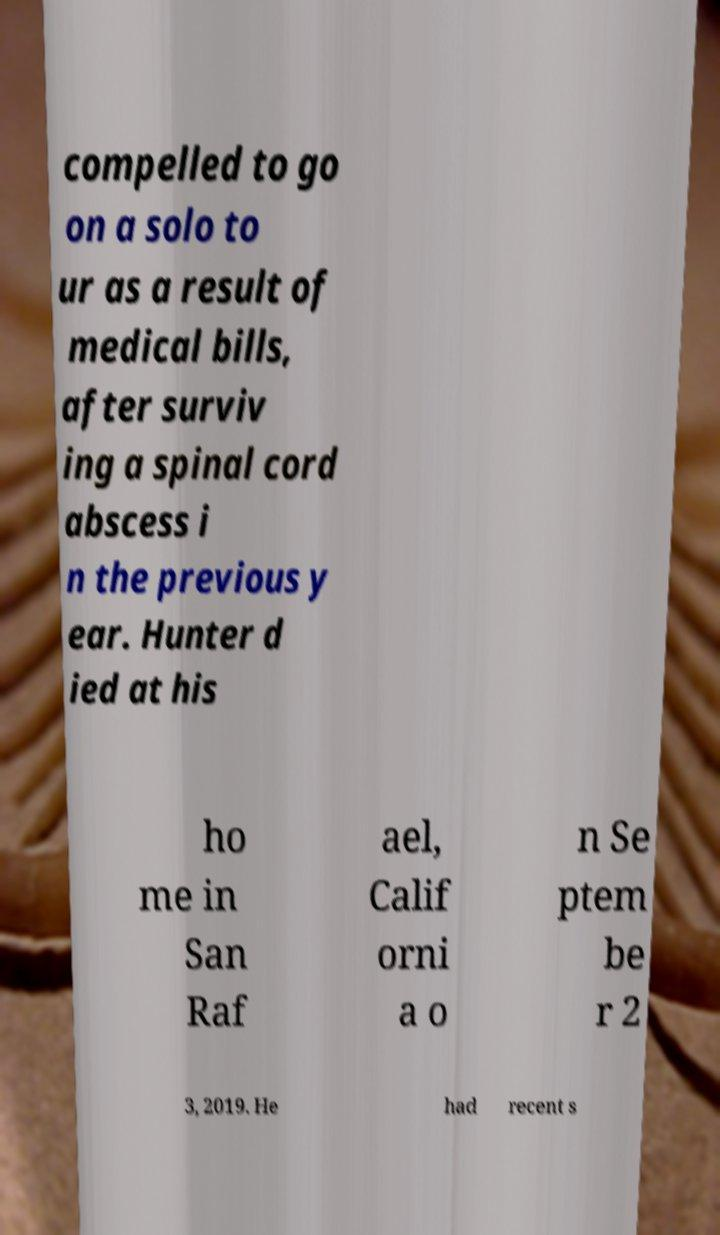I need the written content from this picture converted into text. Can you do that? compelled to go on a solo to ur as a result of medical bills, after surviv ing a spinal cord abscess i n the previous y ear. Hunter d ied at his ho me in San Raf ael, Calif orni a o n Se ptem be r 2 3, 2019. He had recent s 